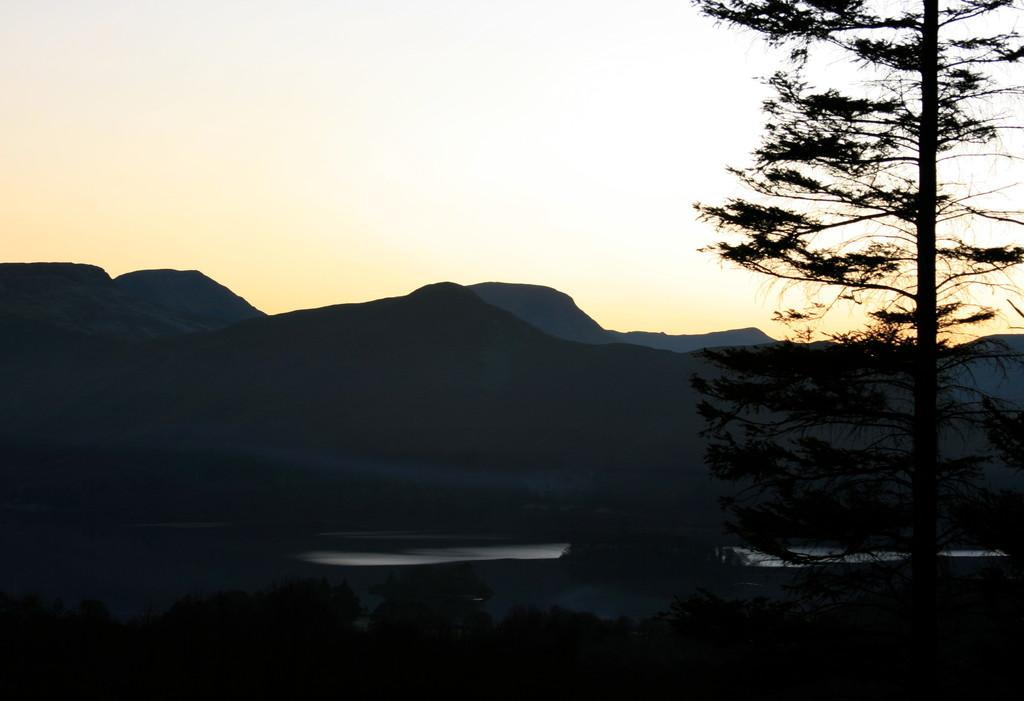What type of vegetation is on the right side of the image? There is a tree on the right side of the image. What is located in the center of the image? There is a lake in the center of the image. What can be seen in the background of the image? Hills and the sky are visible in the background of the image. How many tables are present in the image? There are no tables visible in the image. Is there a swing hanging from the tree in the image? There is no swing present in the image; only a tree, a lake, hills, and the sky are visible. 